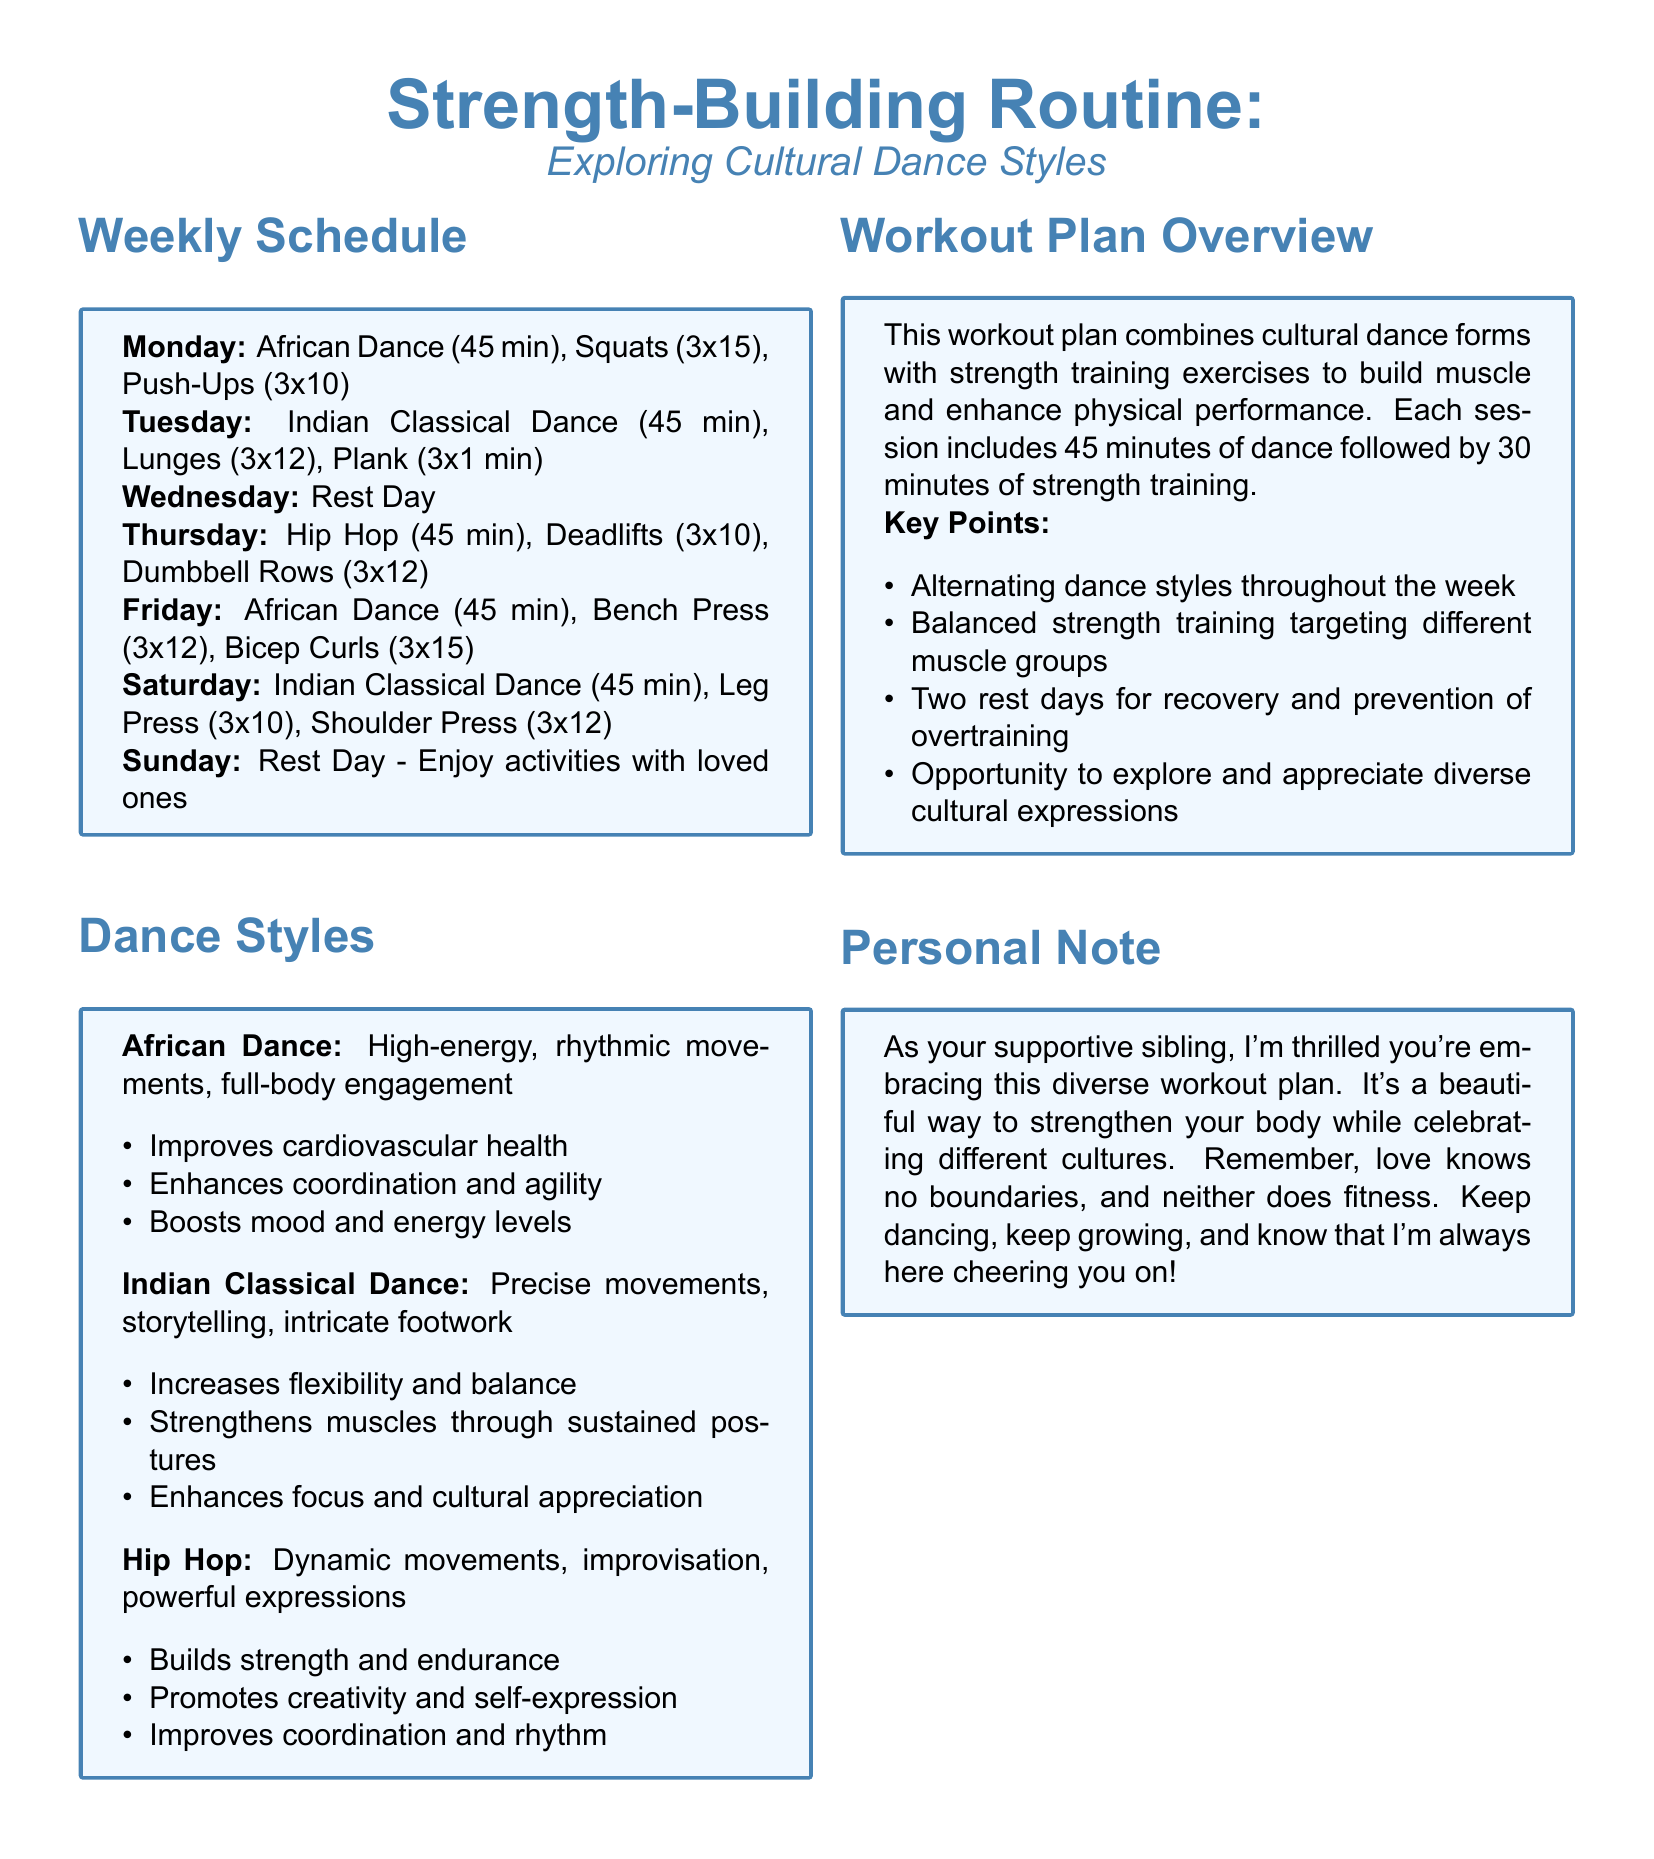What is the duration of African Dance sessions? African Dance sessions are 45 minutes long as stated in the schedule.
Answer: 45 min How many strength training exercises are paired with Indian Classical Dance? Two strength training exercises are paired with Indian Classical Dance in the weekly schedule.
Answer: 2 What exercises are performed on Thursday? Thursday includes Hip Hop, Deadlifts, and Dumbbell Rows according to the weekly schedule.
Answer: Hip Hop, Deadlifts, Dumbbell Rows How many rest days are included in the workout plan? The document specifies two rest days in the weekly schedule for recovery.
Answer: 2 What is the main goal of this workout plan? The main goal is to build muscle and enhance physical performance through a combination of dance and strength training.
Answer: Build muscle and enhance physical performance Which cultural dance form is practiced on Fridays? The cultural dance form practiced on Fridays is African Dance as indicated in the schedule.
Answer: African Dance What type of fitness does Hip Hop promote? Hip Hop promotes creativity and self-expression as mentioned in the Dance Styles section.
Answer: Creativity and self-expression What should you do on rest days according to the document? On rest days, the document suggests enjoying activities with loved ones.
Answer: Enjoy activities with loved ones 